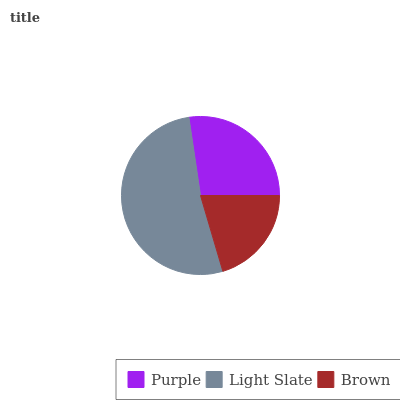Is Brown the minimum?
Answer yes or no. Yes. Is Light Slate the maximum?
Answer yes or no. Yes. Is Light Slate the minimum?
Answer yes or no. No. Is Brown the maximum?
Answer yes or no. No. Is Light Slate greater than Brown?
Answer yes or no. Yes. Is Brown less than Light Slate?
Answer yes or no. Yes. Is Brown greater than Light Slate?
Answer yes or no. No. Is Light Slate less than Brown?
Answer yes or no. No. Is Purple the high median?
Answer yes or no. Yes. Is Purple the low median?
Answer yes or no. Yes. Is Brown the high median?
Answer yes or no. No. Is Light Slate the low median?
Answer yes or no. No. 